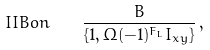<formula> <loc_0><loc_0><loc_500><loc_500>I I B o n \quad \frac { B } { \{ 1 , \Omega ( - 1 ) ^ { F _ { L } } I _ { x y } \} } \, ,</formula> 